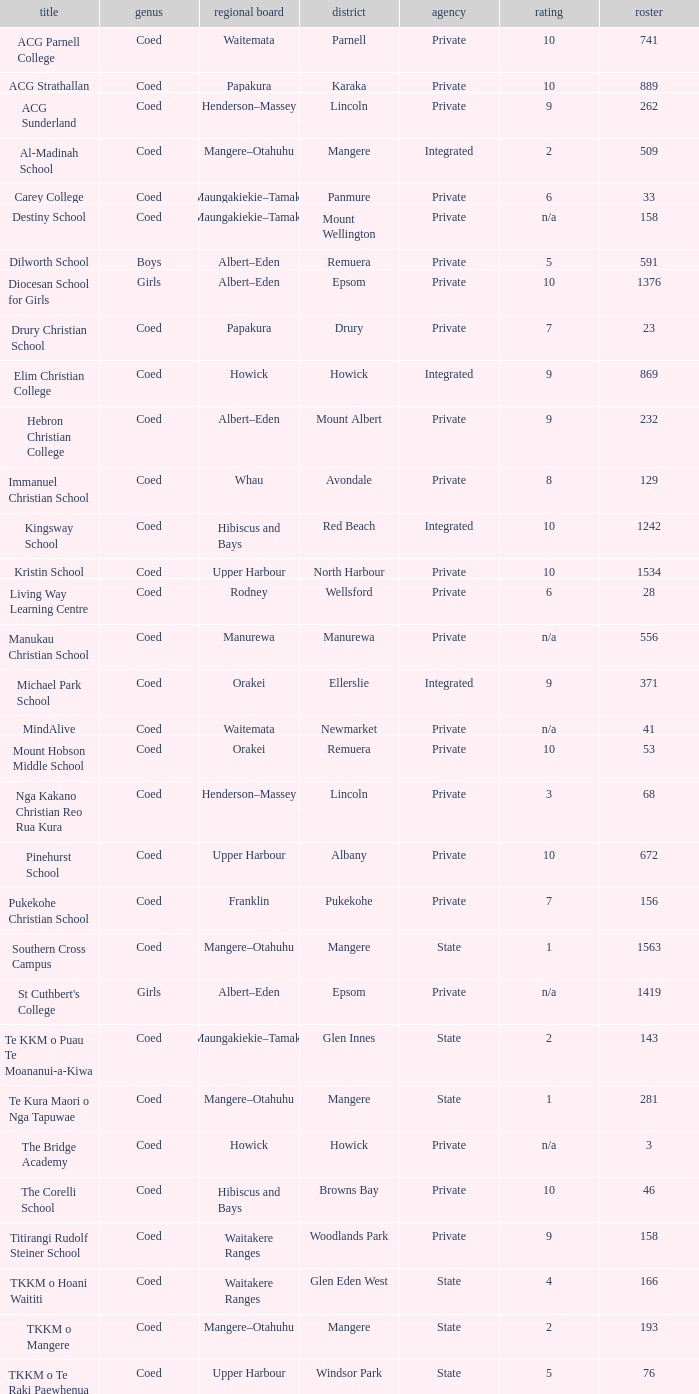What is the name when the local board is albert–eden, and a Decile of 9? Hebron Christian College. 